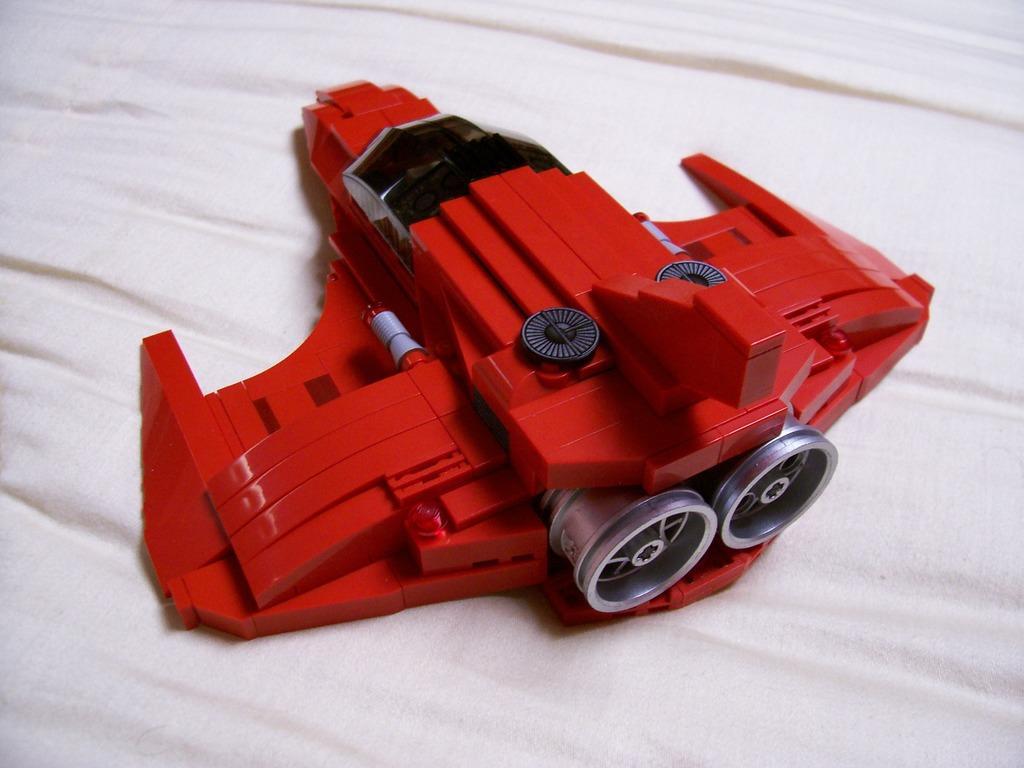In one or two sentences, can you explain what this image depicts? In the center of the image we can see a toy placed on the cloth. 